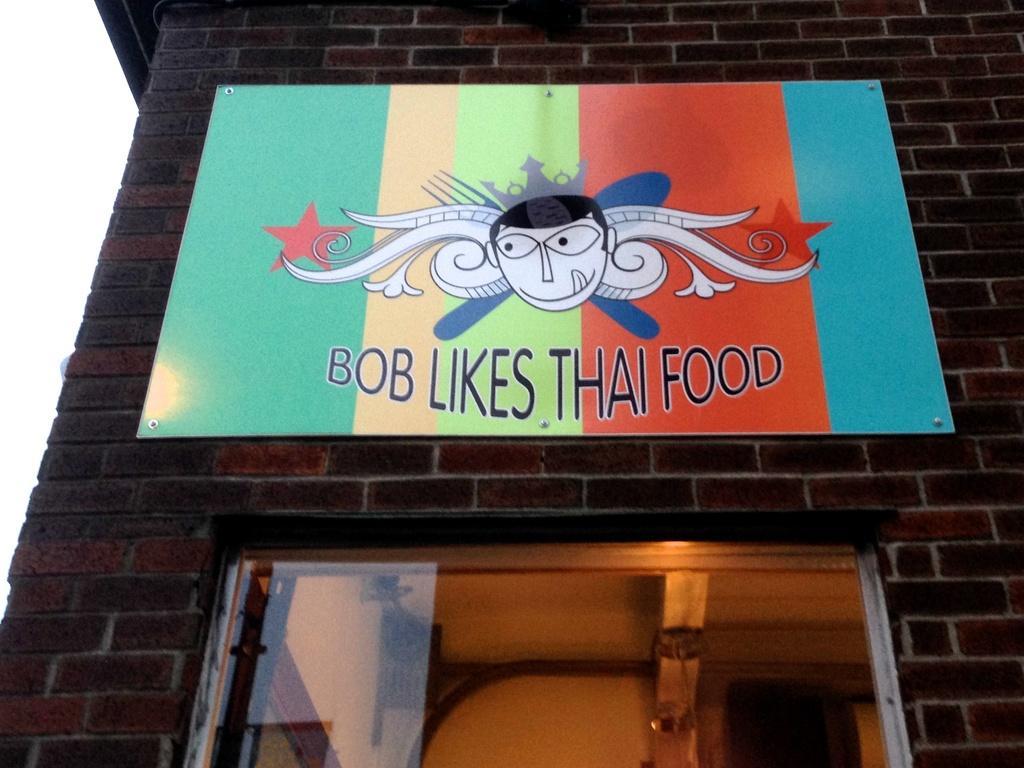How would you summarize this image in a sentence or two? In this image we can see there is a building and door. There is a board on the building with something written on it. 